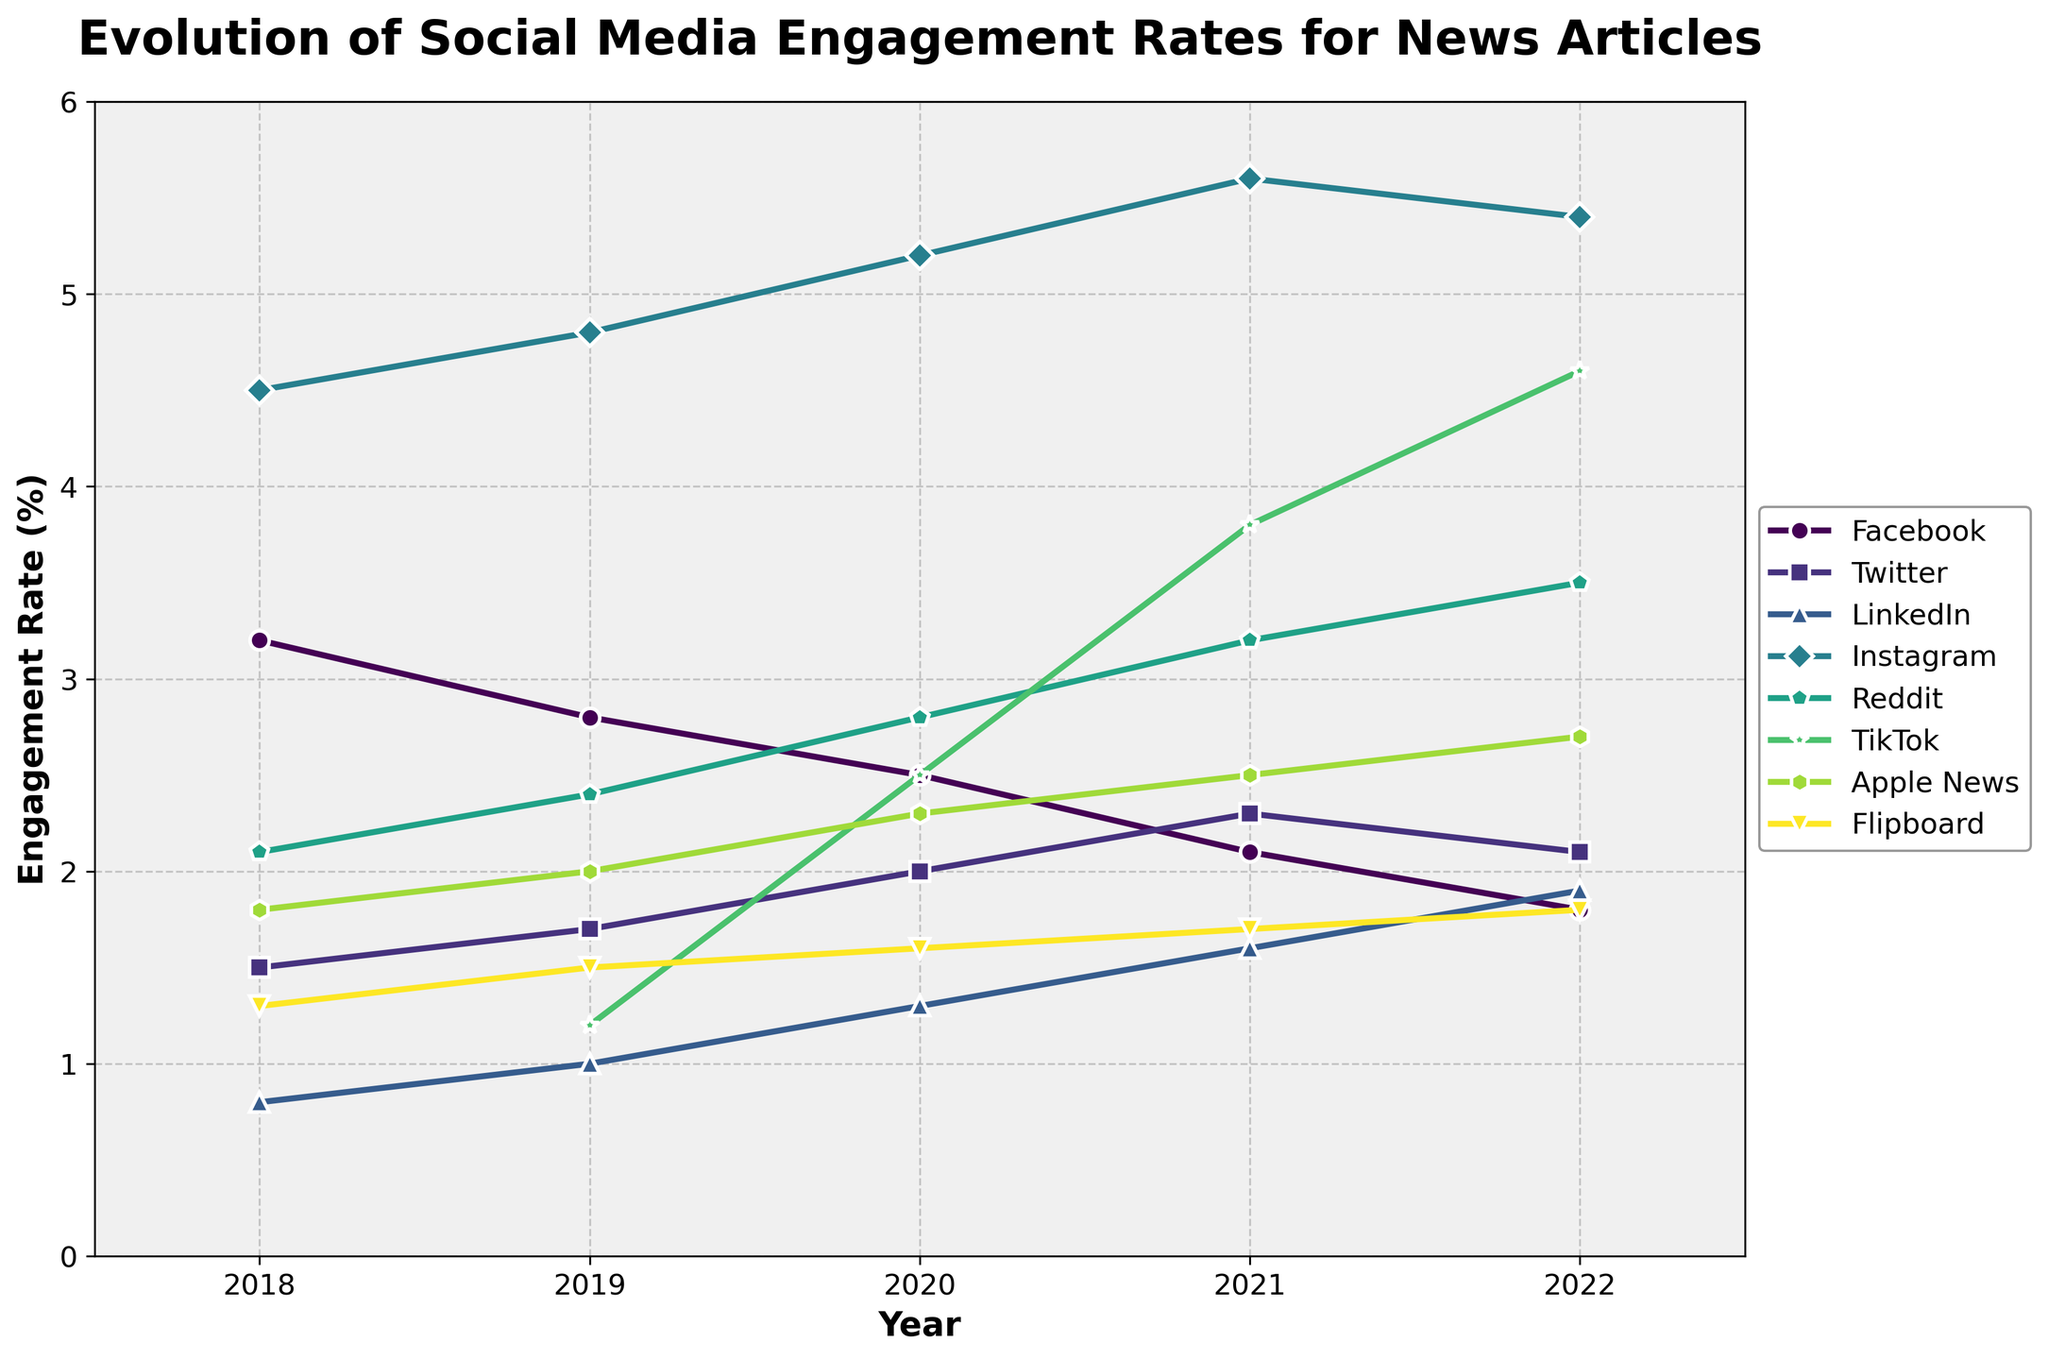Which platform had the highest engagement rate in 2022? The platforms' engagement rates in 2022 are visually represented in the chart. The highest line corresponds to Instagram with a value of 5.4%.
Answer: Instagram How much did TikTok's engagement rate increase from 2020 to 2021? Look at TikTok's values in 2020 (2.5%) and 2021 (3.8%). Subtract the 2020 value from the 2021 value: 3.8% - 2.5% = 1.3%.
Answer: 1.3% Which two platforms had a crossing point around 2020? Identify lines that intersect around 2020. The lines for TikTok and Facebook cross around this year.
Answer: TikTok and Facebook By how much did Reddit's engagement rate change from 2019 to 2022? For Reddit, the engagement rates in 2019 and 2022 are 2.4% and 3.5%, respectively. Determine the difference: 3.5% - 2.4% = 1.1%.
Answer: 1.1% Which platform shows the most consistent increase in engagement rates from 2018 to 2022? Examine the trend of each platform's engagement rates. LinkedIn's line shows a steady increase each year without any decline.
Answer: LinkedIn What is the average engagement rate of Facebook over the five years? Facebook's engagement rates for the years are 3.2%, 2.8%, 2.5%, 2.1%, and 1.8%. Calculate the average: (3.2 + 2.8 + 2.5 + 2.1 + 1.8) / 5 = 2.48%.
Answer: 2.48% Compare the engagement rate growth of Apple News and Flipboard from 2018 to 2022. Which one grew more? Apple News grew from 1.8% to 2.7% (0.9% increase). Flipboard grew from 1.3% to 1.8% (0.5% increase). Apple News had a larger growth.
Answer: Apple News Which platform had the largest drop in engagement rate between any two consecutive years? Determine the largest drop by comparing differences between each consecutive year for all platforms. Facebook had the largest drop from 2018 (3.2%) to 2019 (2.8%), a 0.4% decrease.
Answer: Facebook What is the median engagement rate for Twitter from 2018 to 2022? Twitter's engagement rates are 1.5%, 1.7%, 2.0%, 2.3%, and 2.1%. Arrange the values in order and find the middle value: 1.5%, 1.7%, 2.0%, 2.1%, 2.3%. The median is 2.0%.
Answer: 2.0% Which platform has shown the highest final year (2022) engagement rate while initially absent in 2018? Platforms absent in 2018 and with values shown in 2022 are TikTok. TikTok had an engagement rate of 4.6% in 2022.
Answer: TikTok 